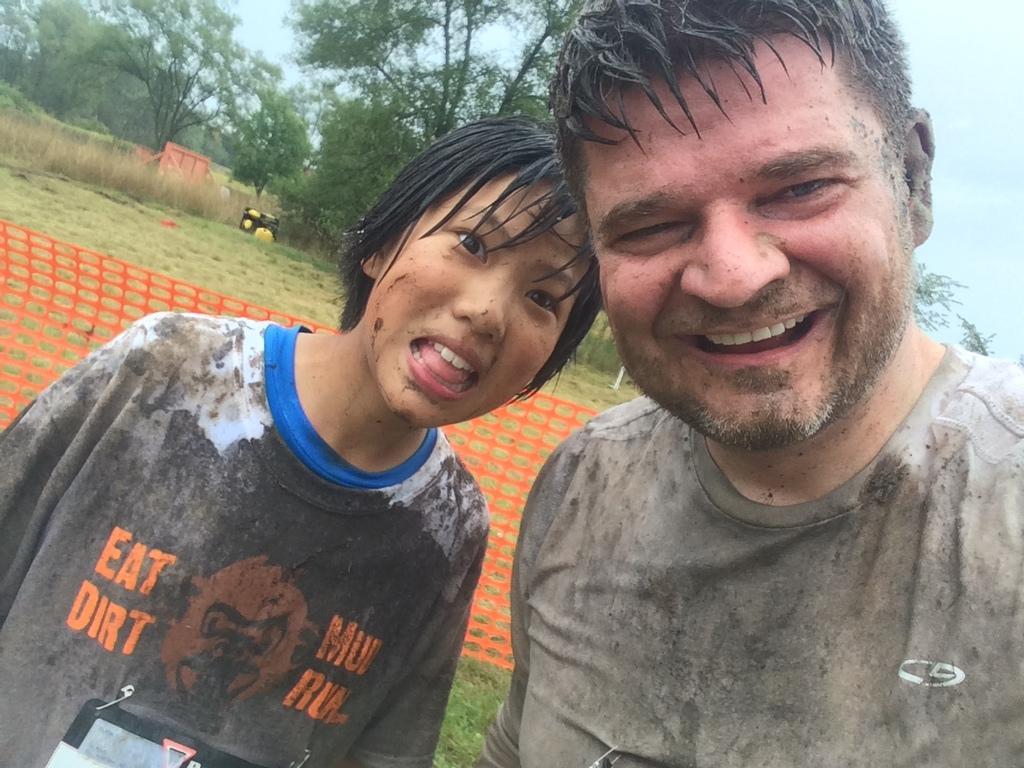Could you give a brief overview of what you see in this image? In this image we can see man and woman standing on the grass. In the background we can see net, trees, plants and sky. 